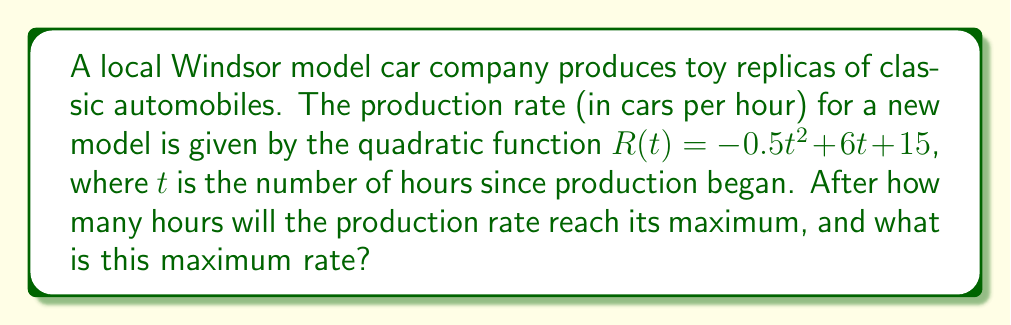Give your solution to this math problem. To solve this problem, we need to follow these steps:

1) The production rate is given by a quadratic function: $R(t) = -0.5t^2 + 6t + 15$

2) For a quadratic function in the form $f(x) = ax^2 + bx + c$, the x-coordinate of the vertex (which gives the maximum or minimum point) is given by the formula: $x = -\frac{b}{2a}$

3) In our case, $a = -0.5$ and $b = 6$. Let's substitute these values:

   $t = -\frac{6}{2(-0.5)} = -\frac{6}{-1} = 6$

4) This means the production rate reaches its maximum after 6 hours.

5) To find the maximum rate, we need to substitute $t = 6$ into the original function:

   $R(6) = -0.5(6)^2 + 6(6) + 15$
   $= -0.5(36) + 36 + 15$
   $= -18 + 36 + 15$
   $= 33$

Therefore, the maximum production rate is 33 cars per hour.
Answer: The production rate reaches its maximum after 6 hours, and the maximum rate is 33 cars per hour. 